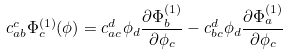Convert formula to latex. <formula><loc_0><loc_0><loc_500><loc_500>c _ { a b } ^ { c } \Phi _ { c } ^ { ( 1 ) } ( \phi ) = c _ { a c } ^ { d } \phi _ { d } \frac { \partial \Phi _ { b } ^ { ( 1 ) } } { \partial \phi _ { c } } - c _ { b c } ^ { d } \phi _ { d } \frac { \partial \Phi _ { a } ^ { ( 1 ) } } { \partial \phi _ { c } }</formula> 